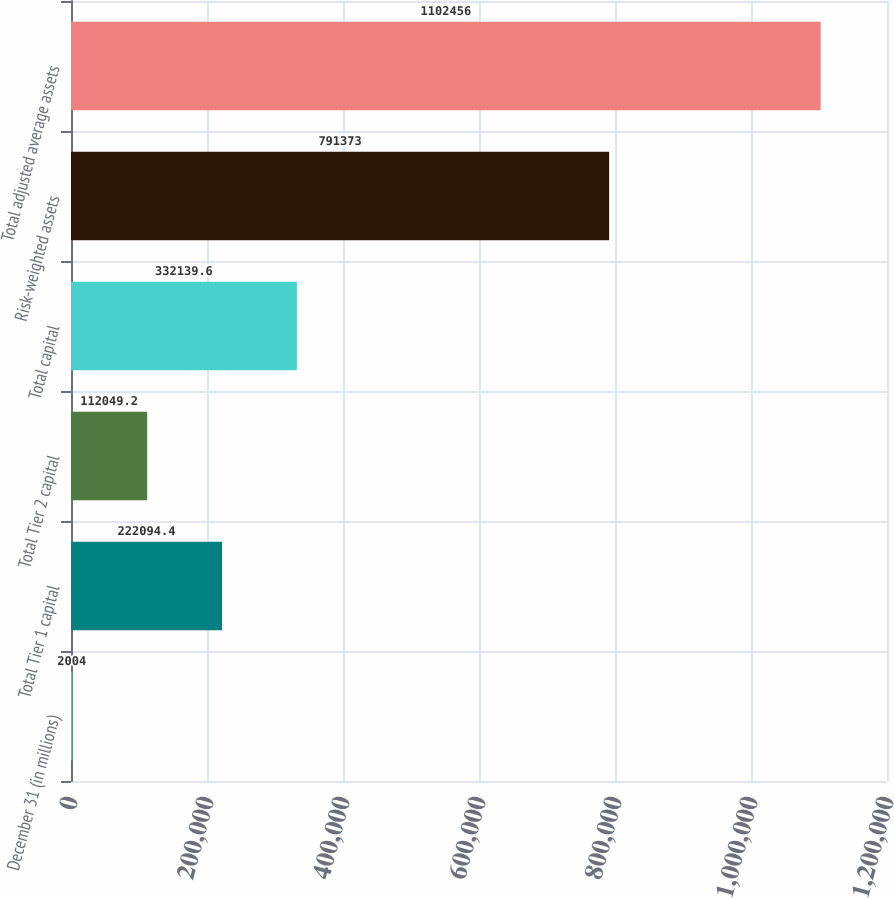Convert chart. <chart><loc_0><loc_0><loc_500><loc_500><bar_chart><fcel>December 31 (in millions)<fcel>Total Tier 1 capital<fcel>Total Tier 2 capital<fcel>Total capital<fcel>Risk-weighted assets<fcel>Total adjusted average assets<nl><fcel>2004<fcel>222094<fcel>112049<fcel>332140<fcel>791373<fcel>1.10246e+06<nl></chart> 